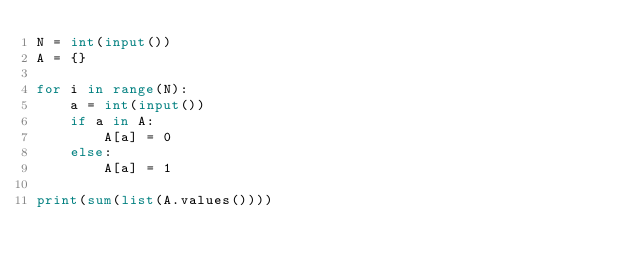<code> <loc_0><loc_0><loc_500><loc_500><_Python_>N = int(input())
A = {}

for i in range(N):
    a = int(input())
    if a in A:
        A[a] = 0
    else:
        A[a] = 1

print(sum(list(A.values())))</code> 